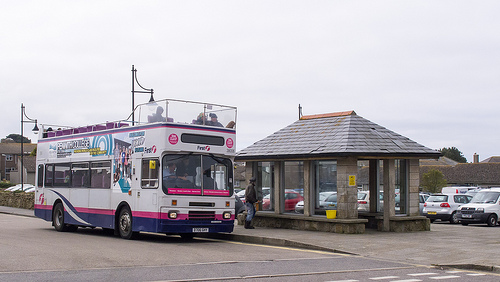What type of vehicle is to the left of the person that is standing? To the left of the person that is standing is a bus. 